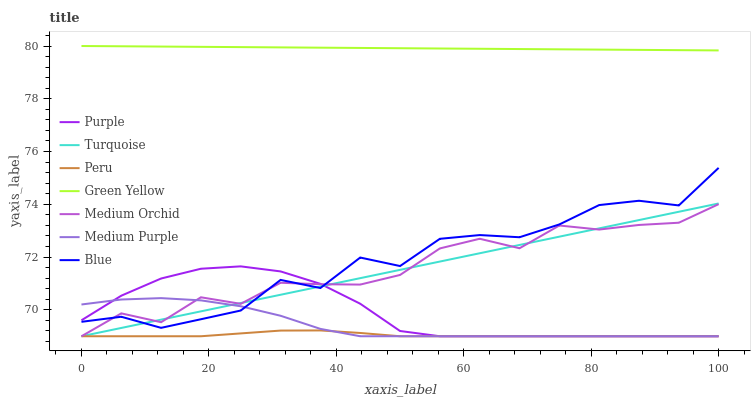Does Peru have the minimum area under the curve?
Answer yes or no. Yes. Does Green Yellow have the maximum area under the curve?
Answer yes or no. Yes. Does Turquoise have the minimum area under the curve?
Answer yes or no. No. Does Turquoise have the maximum area under the curve?
Answer yes or no. No. Is Turquoise the smoothest?
Answer yes or no. Yes. Is Blue the roughest?
Answer yes or no. Yes. Is Purple the smoothest?
Answer yes or no. No. Is Purple the roughest?
Answer yes or no. No. Does Turquoise have the lowest value?
Answer yes or no. Yes. Does Green Yellow have the lowest value?
Answer yes or no. No. Does Green Yellow have the highest value?
Answer yes or no. Yes. Does Turquoise have the highest value?
Answer yes or no. No. Is Medium Purple less than Green Yellow?
Answer yes or no. Yes. Is Green Yellow greater than Purple?
Answer yes or no. Yes. Does Peru intersect Medium Orchid?
Answer yes or no. Yes. Is Peru less than Medium Orchid?
Answer yes or no. No. Is Peru greater than Medium Orchid?
Answer yes or no. No. Does Medium Purple intersect Green Yellow?
Answer yes or no. No. 